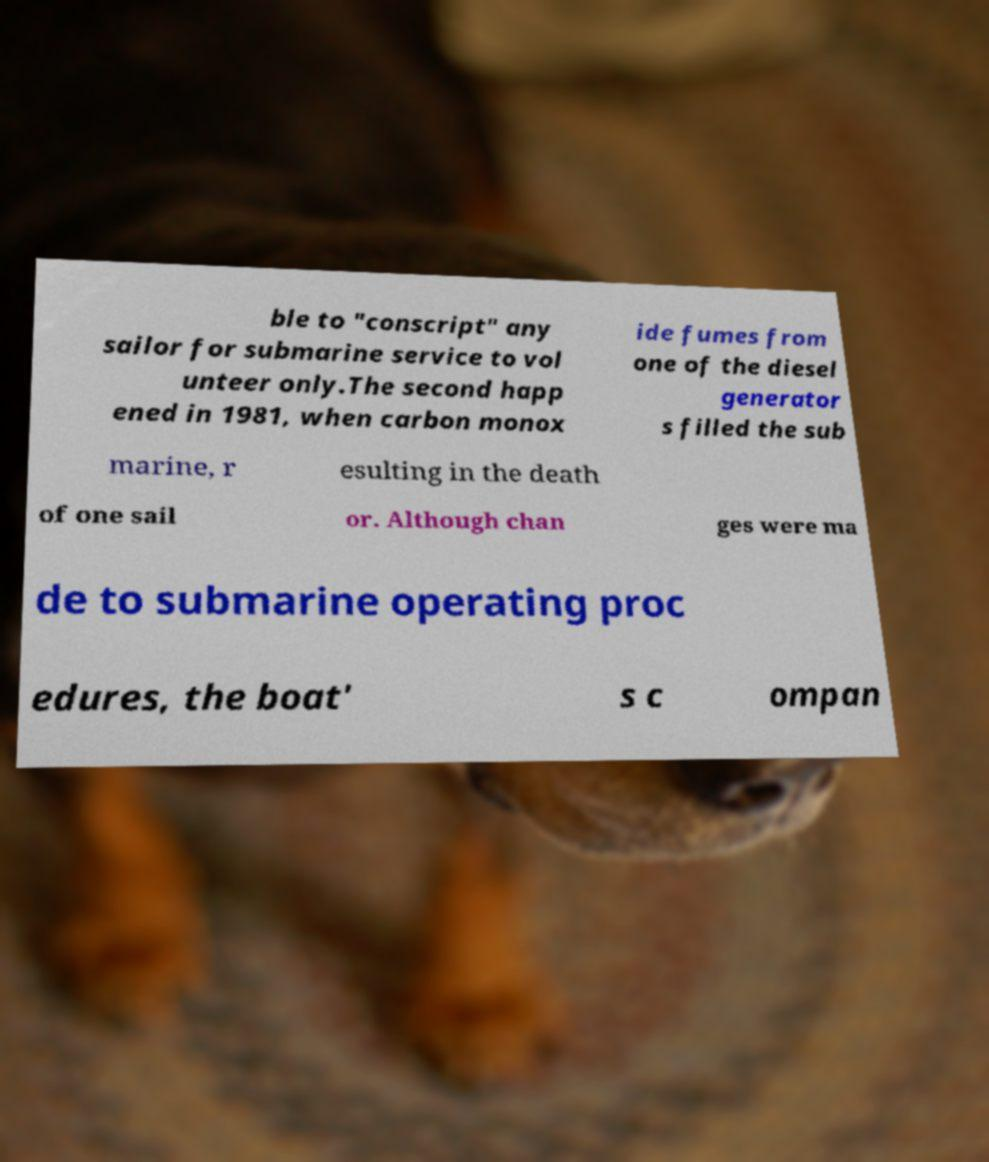Can you accurately transcribe the text from the provided image for me? ble to "conscript" any sailor for submarine service to vol unteer only.The second happ ened in 1981, when carbon monox ide fumes from one of the diesel generator s filled the sub marine, r esulting in the death of one sail or. Although chan ges were ma de to submarine operating proc edures, the boat' s c ompan 